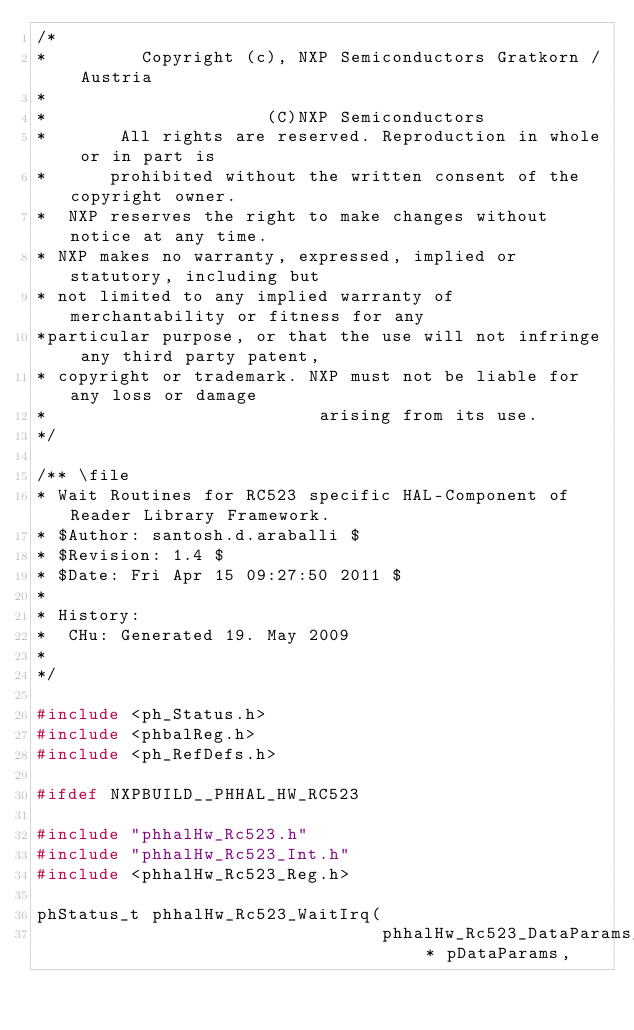<code> <loc_0><loc_0><loc_500><loc_500><_C_>/*
*         Copyright (c), NXP Semiconductors Gratkorn / Austria
*
*                     (C)NXP Semiconductors
*       All rights are reserved. Reproduction in whole or in part is 
*      prohibited without the written consent of the copyright owner.
*  NXP reserves the right to make changes without notice at any time.
* NXP makes no warranty, expressed, implied or statutory, including but
* not limited to any implied warranty of merchantability or fitness for any
*particular purpose, or that the use will not infringe any third party patent,
* copyright or trademark. NXP must not be liable for any loss or damage
*                          arising from its use.
*/

/** \file
* Wait Routines for RC523 specific HAL-Component of Reader Library Framework.
* $Author: santosh.d.araballi $
* $Revision: 1.4 $
* $Date: Fri Apr 15 09:27:50 2011 $
*
* History:
*  CHu: Generated 19. May 2009
*
*/

#include <ph_Status.h>
#include <phbalReg.h>
#include <ph_RefDefs.h>

#ifdef NXPBUILD__PHHAL_HW_RC523

#include "phhalHw_Rc523.h"
#include "phhalHw_Rc523_Int.h"
#include <phhalHw_Rc523_Reg.h>

phStatus_t phhalHw_Rc523_WaitIrq(
                                 phhalHw_Rc523_DataParams_t * pDataParams,</code> 